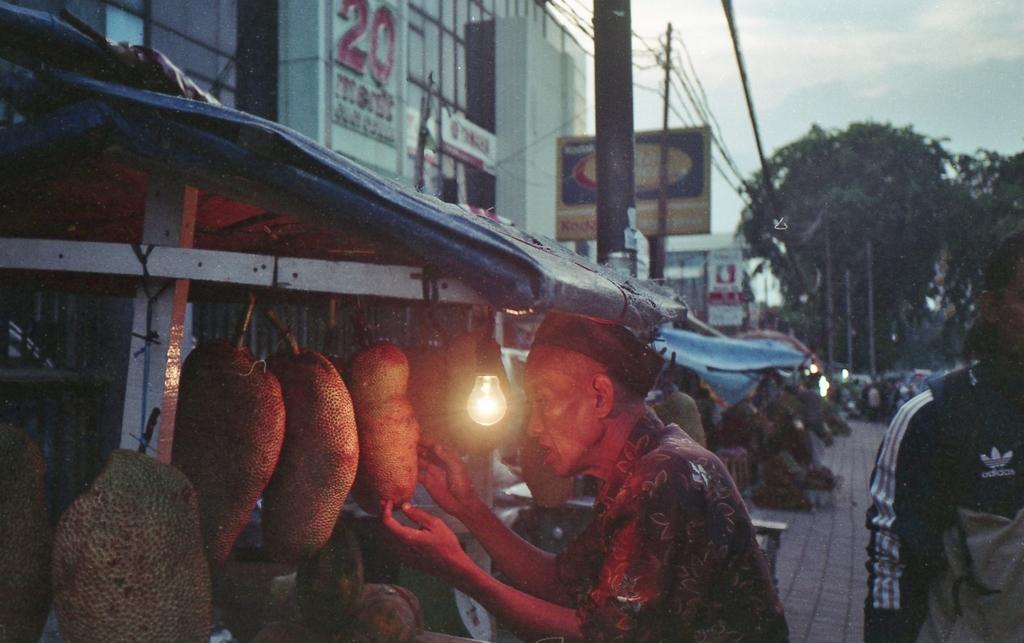Who is the main subject in the image? There is an old man in the middle of the image. What is in front of the old man? There are jackfruits and a bulb in front of the old man. What can be seen in the background of the image? There are buildings, trees, and the sky visible in the background of the image. What is the condition of the pot in the image? There is no pot present in the image. How do the acoustics of the old man's voice sound in the image? The image does not provide any information about the old man's voice or the acoustics of the environment. 